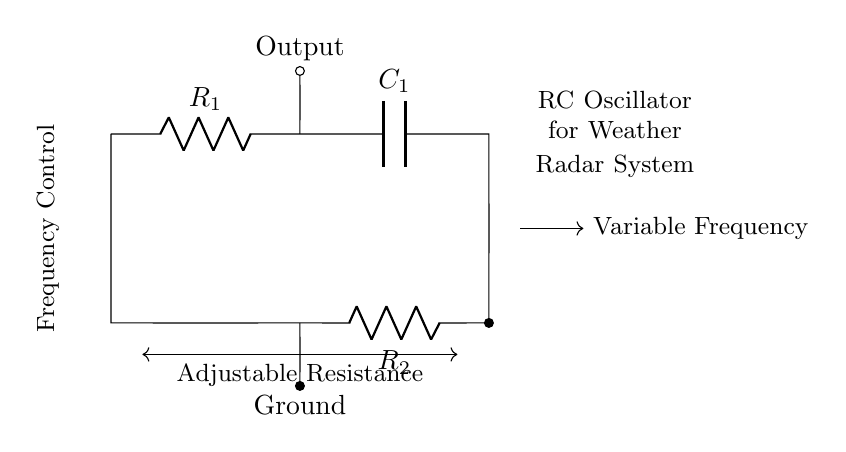What are the components of the circuit? The circuit consists of two resistors and one capacitor, which are used to form an RC oscillator.
Answer: Resistor, Capacitor What is the function of the variable frequency output? The variable frequency output allows for the generation of different frequencies, which can be adjusted for specific radar applications.
Answer: Frequency generation How many resistors are in the circuit? The diagram clearly shows two resistors labeled as R1 and R2 connected in the circuit.
Answer: Two What role does the capacitor play in this RC oscillator? The capacitor stores and releases charge, which is crucial for creating oscillations in the circuit, thereby determining the frequency along with the resistors.
Answer: Frequency control How is frequency adjusted in this circuit? The frequency is adjusted by changing the resistance of R1 or R2, which alters the time constant of the RC circuit, affecting the oscillation frequency.
Answer: Adjustable Resistance What happens if the resistance is increased? Increasing the resistance will increase the time constant of the circuit, thereby decreasing the oscillation frequency of the output signal.
Answer: Decrease in frequency What type of circuit is depicted here? The circuit is an RC oscillator, which is specifically designed for generating variable frequency signals.
Answer: RC oscillator 